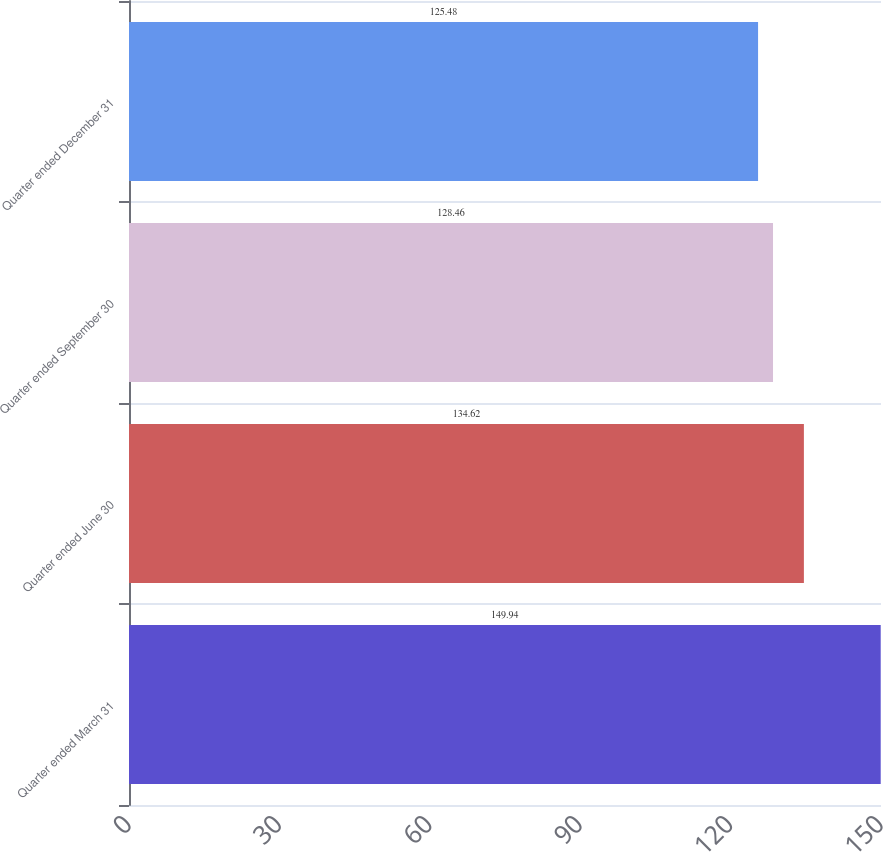<chart> <loc_0><loc_0><loc_500><loc_500><bar_chart><fcel>Quarter ended March 31<fcel>Quarter ended June 30<fcel>Quarter ended September 30<fcel>Quarter ended December 31<nl><fcel>149.94<fcel>134.62<fcel>128.46<fcel>125.48<nl></chart> 